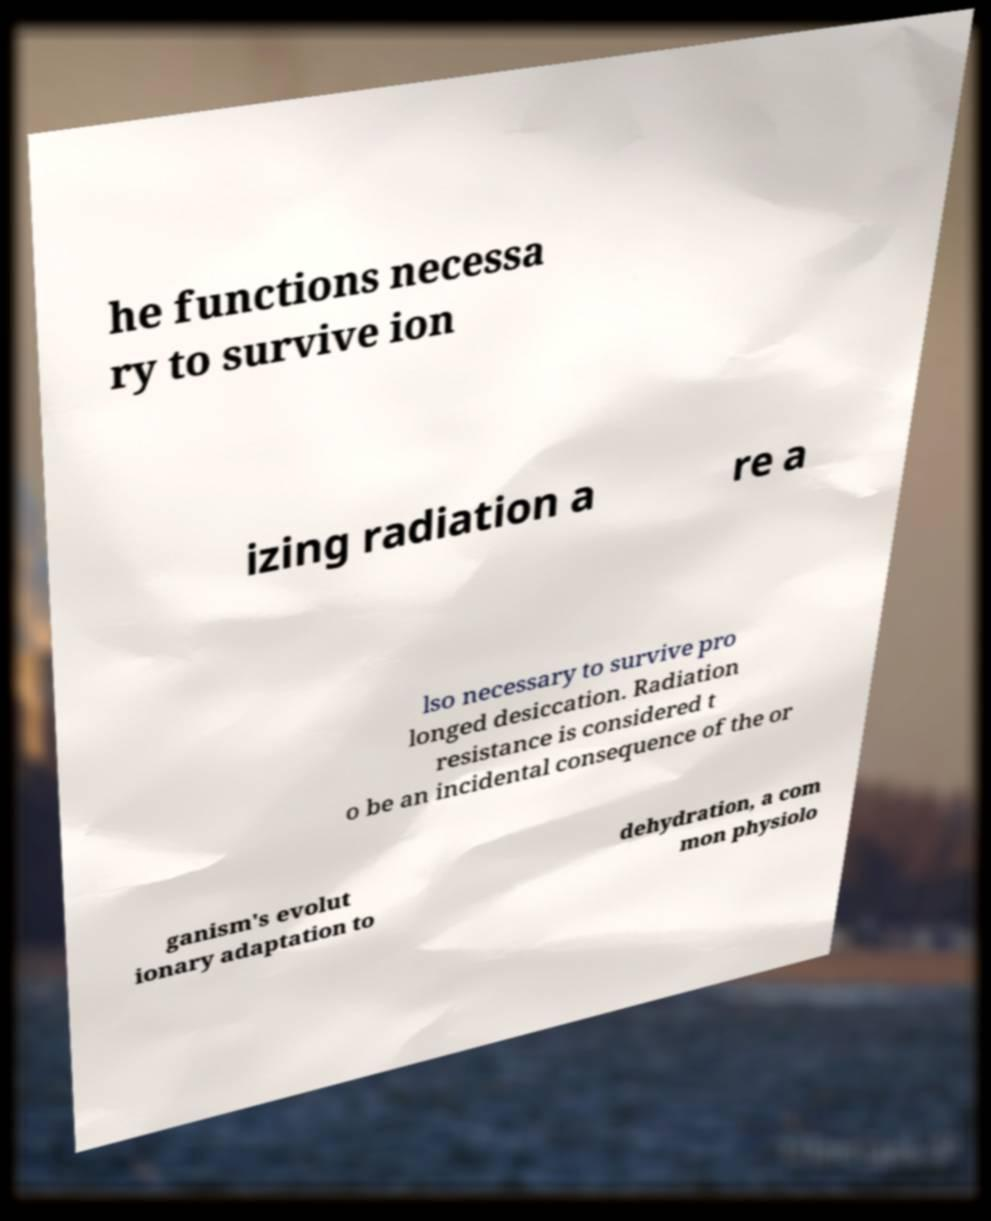There's text embedded in this image that I need extracted. Can you transcribe it verbatim? he functions necessa ry to survive ion izing radiation a re a lso necessary to survive pro longed desiccation. Radiation resistance is considered t o be an incidental consequence of the or ganism's evolut ionary adaptation to dehydration, a com mon physiolo 